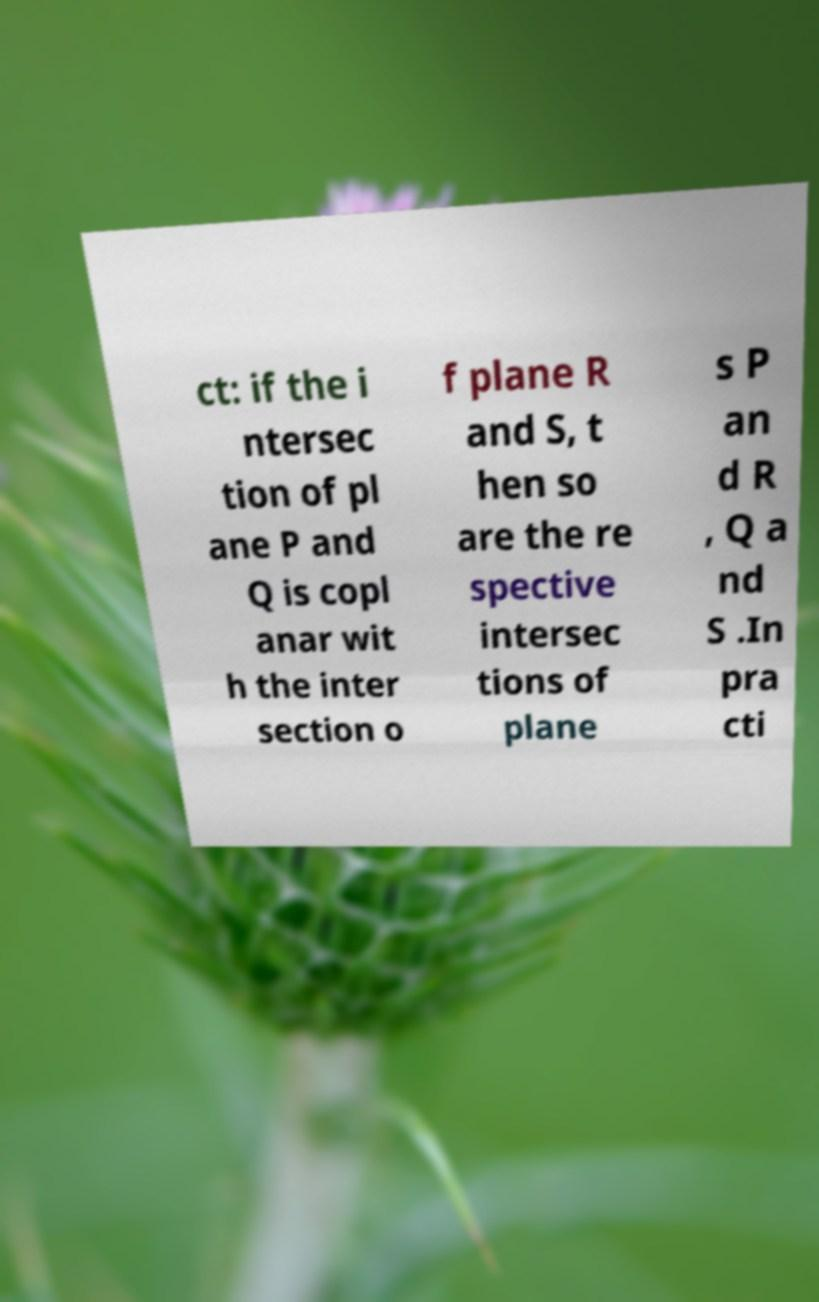What messages or text are displayed in this image? I need them in a readable, typed format. ct: if the i ntersec tion of pl ane P and Q is copl anar wit h the inter section o f plane R and S, t hen so are the re spective intersec tions of plane s P an d R , Q a nd S .In pra cti 